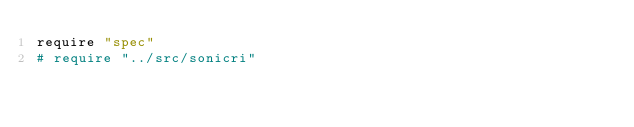<code> <loc_0><loc_0><loc_500><loc_500><_Crystal_>require "spec"
# require "../src/sonicri"
</code> 